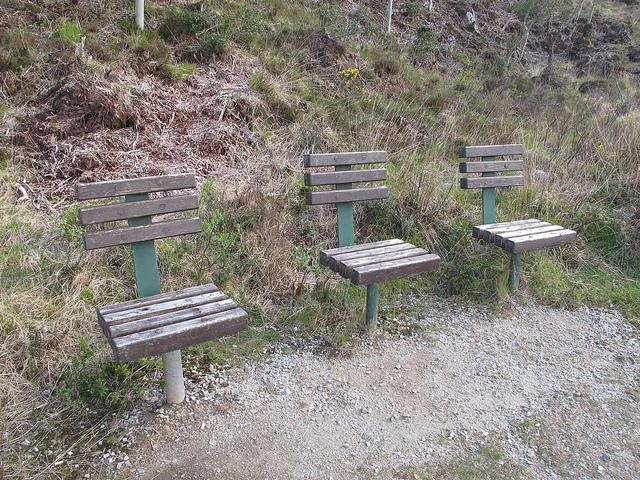What color is the second furthest away bench?
Be succinct. Brown. How many legs are on the bench?
Be succinct. 1. What are the seats made out of?
Give a very brief answer. Wood. How many seats are there in the picture?
Give a very brief answer. 3. Is this taken in a mountain?
Be succinct. Yes. Is the garden lush?
Short answer required. No. Can more than three people at a time sit on this bench?
Concise answer only. No. How many places to sit are available?
Concise answer only. 3. 